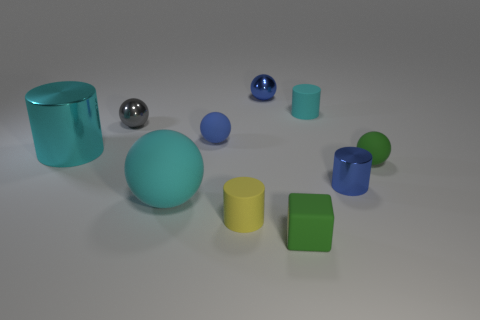Are there any large metal objects that are on the right side of the blue ball that is in front of the metal sphere that is on the left side of the small blue matte sphere?
Your answer should be very brief. No. Is the number of small shiny objects in front of the small green rubber ball less than the number of big rubber things to the right of the small yellow matte cylinder?
Offer a terse response. No. What number of other balls have the same material as the big cyan ball?
Keep it short and to the point. 2. Do the cyan sphere and the green ball that is in front of the gray metallic ball have the same size?
Your answer should be very brief. No. There is a big cylinder that is the same color as the large rubber ball; what is its material?
Provide a succinct answer. Metal. How big is the green object right of the shiny object to the right of the blue thing behind the gray sphere?
Offer a terse response. Small. Is the number of matte cylinders that are left of the green cube greater than the number of big cyan balls behind the large matte ball?
Make the answer very short. Yes. How many small green rubber things are on the right side of the metallic ball on the left side of the large cyan matte object?
Offer a very short reply. 2. Are there any rubber cylinders that have the same color as the small metal cylinder?
Your answer should be very brief. No. Does the yellow cylinder have the same size as the blue metallic cylinder?
Provide a short and direct response. Yes. 